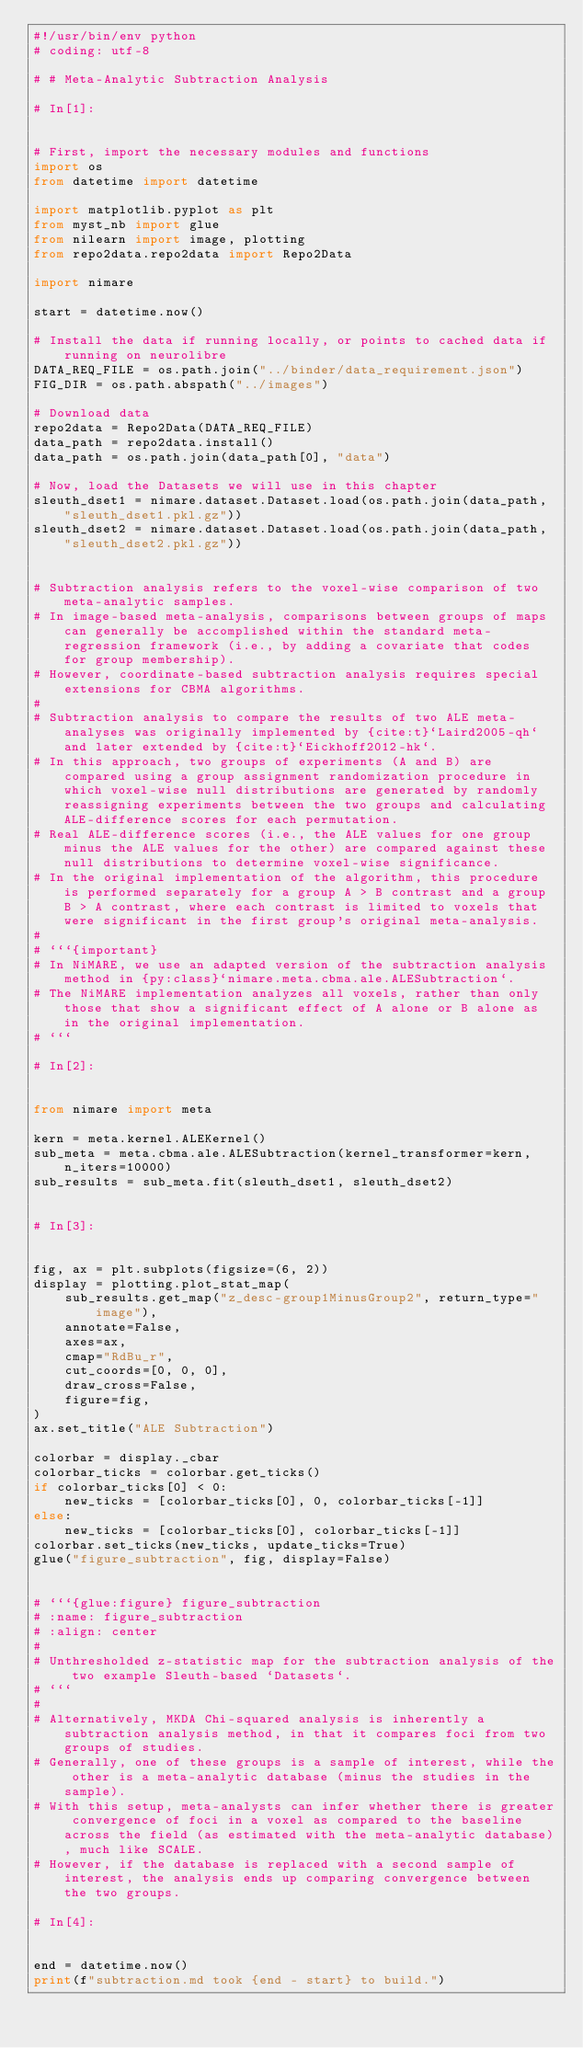Convert code to text. <code><loc_0><loc_0><loc_500><loc_500><_Python_>#!/usr/bin/env python
# coding: utf-8

# # Meta-Analytic Subtraction Analysis

# In[1]:


# First, import the necessary modules and functions
import os
from datetime import datetime

import matplotlib.pyplot as plt
from myst_nb import glue
from nilearn import image, plotting
from repo2data.repo2data import Repo2Data

import nimare

start = datetime.now()

# Install the data if running locally, or points to cached data if running on neurolibre
DATA_REQ_FILE = os.path.join("../binder/data_requirement.json")
FIG_DIR = os.path.abspath("../images")

# Download data
repo2data = Repo2Data(DATA_REQ_FILE)
data_path = repo2data.install()
data_path = os.path.join(data_path[0], "data")

# Now, load the Datasets we will use in this chapter
sleuth_dset1 = nimare.dataset.Dataset.load(os.path.join(data_path, "sleuth_dset1.pkl.gz"))
sleuth_dset2 = nimare.dataset.Dataset.load(os.path.join(data_path, "sleuth_dset2.pkl.gz"))


# Subtraction analysis refers to the voxel-wise comparison of two meta-analytic samples.
# In image-based meta-analysis, comparisons between groups of maps can generally be accomplished within the standard meta-regression framework (i.e., by adding a covariate that codes for group membership).
# However, coordinate-based subtraction analysis requires special extensions for CBMA algorithms.
# 
# Subtraction analysis to compare the results of two ALE meta-analyses was originally implemented by {cite:t}`Laird2005-qh` and later extended by {cite:t}`Eickhoff2012-hk`.
# In this approach, two groups of experiments (A and B) are compared using a group assignment randomization procedure in which voxel-wise null distributions are generated by randomly reassigning experiments between the two groups and calculating ALE-difference scores for each permutation.
# Real ALE-difference scores (i.e., the ALE values for one group minus the ALE values for the other) are compared against these null distributions to determine voxel-wise significance.
# In the original implementation of the algorithm, this procedure is performed separately for a group A > B contrast and a group B > A contrast, where each contrast is limited to voxels that were significant in the first group's original meta-analysis.
# 
# ```{important}
# In NiMARE, we use an adapted version of the subtraction analysis method in {py:class}`nimare.meta.cbma.ale.ALESubtraction`.
# The NiMARE implementation analyzes all voxels, rather than only those that show a significant effect of A alone or B alone as in the original implementation.
# ```

# In[2]:


from nimare import meta

kern = meta.kernel.ALEKernel()
sub_meta = meta.cbma.ale.ALESubtraction(kernel_transformer=kern, n_iters=10000)
sub_results = sub_meta.fit(sleuth_dset1, sleuth_dset2)


# In[3]:


fig, ax = plt.subplots(figsize=(6, 2))
display = plotting.plot_stat_map(
    sub_results.get_map("z_desc-group1MinusGroup2", return_type="image"),
    annotate=False,
    axes=ax,
    cmap="RdBu_r",
    cut_coords=[0, 0, 0],
    draw_cross=False,
    figure=fig,
)
ax.set_title("ALE Subtraction")

colorbar = display._cbar
colorbar_ticks = colorbar.get_ticks()
if colorbar_ticks[0] < 0:
    new_ticks = [colorbar_ticks[0], 0, colorbar_ticks[-1]]
else:
    new_ticks = [colorbar_ticks[0], colorbar_ticks[-1]]
colorbar.set_ticks(new_ticks, update_ticks=True)
glue("figure_subtraction", fig, display=False)


# ```{glue:figure} figure_subtraction
# :name: figure_subtraction
# :align: center
# 
# Unthresholded z-statistic map for the subtraction analysis of the two example Sleuth-based `Datasets`.
# ```
# 
# Alternatively, MKDA Chi-squared analysis is inherently a subtraction analysis method, in that it compares foci from two groups of studies.
# Generally, one of these groups is a sample of interest, while the other is a meta-analytic database (minus the studies in the sample).
# With this setup, meta-analysts can infer whether there is greater convergence of foci in a voxel as compared to the baseline across the field (as estimated with the meta-analytic database), much like SCALE.
# However, if the database is replaced with a second sample of interest, the analysis ends up comparing convergence between the two groups.

# In[4]:


end = datetime.now()
print(f"subtraction.md took {end - start} to build.")

</code> 